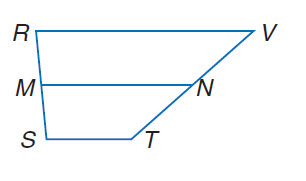Question: R S T V is a trapezoid with bases R V and S T and median M N. Find x if M N = 60, S T = 4 x - 1, and R V = 6 x + 11.
Choices:
A. 11
B. 44
C. 60
D. 77
Answer with the letter. Answer: A 